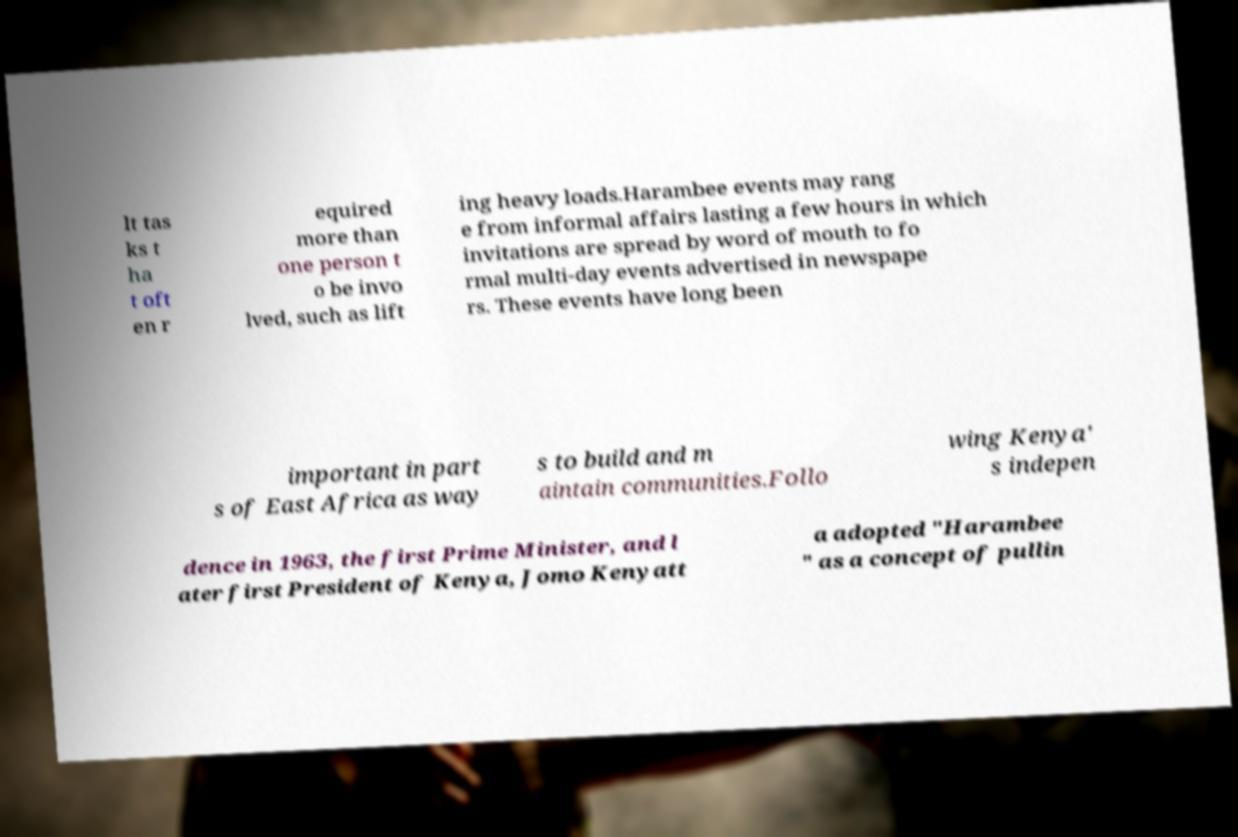There's text embedded in this image that I need extracted. Can you transcribe it verbatim? lt tas ks t ha t oft en r equired more than one person t o be invo lved, such as lift ing heavy loads.Harambee events may rang e from informal affairs lasting a few hours in which invitations are spread by word of mouth to fo rmal multi-day events advertised in newspape rs. These events have long been important in part s of East Africa as way s to build and m aintain communities.Follo wing Kenya' s indepen dence in 1963, the first Prime Minister, and l ater first President of Kenya, Jomo Kenyatt a adopted "Harambee " as a concept of pullin 